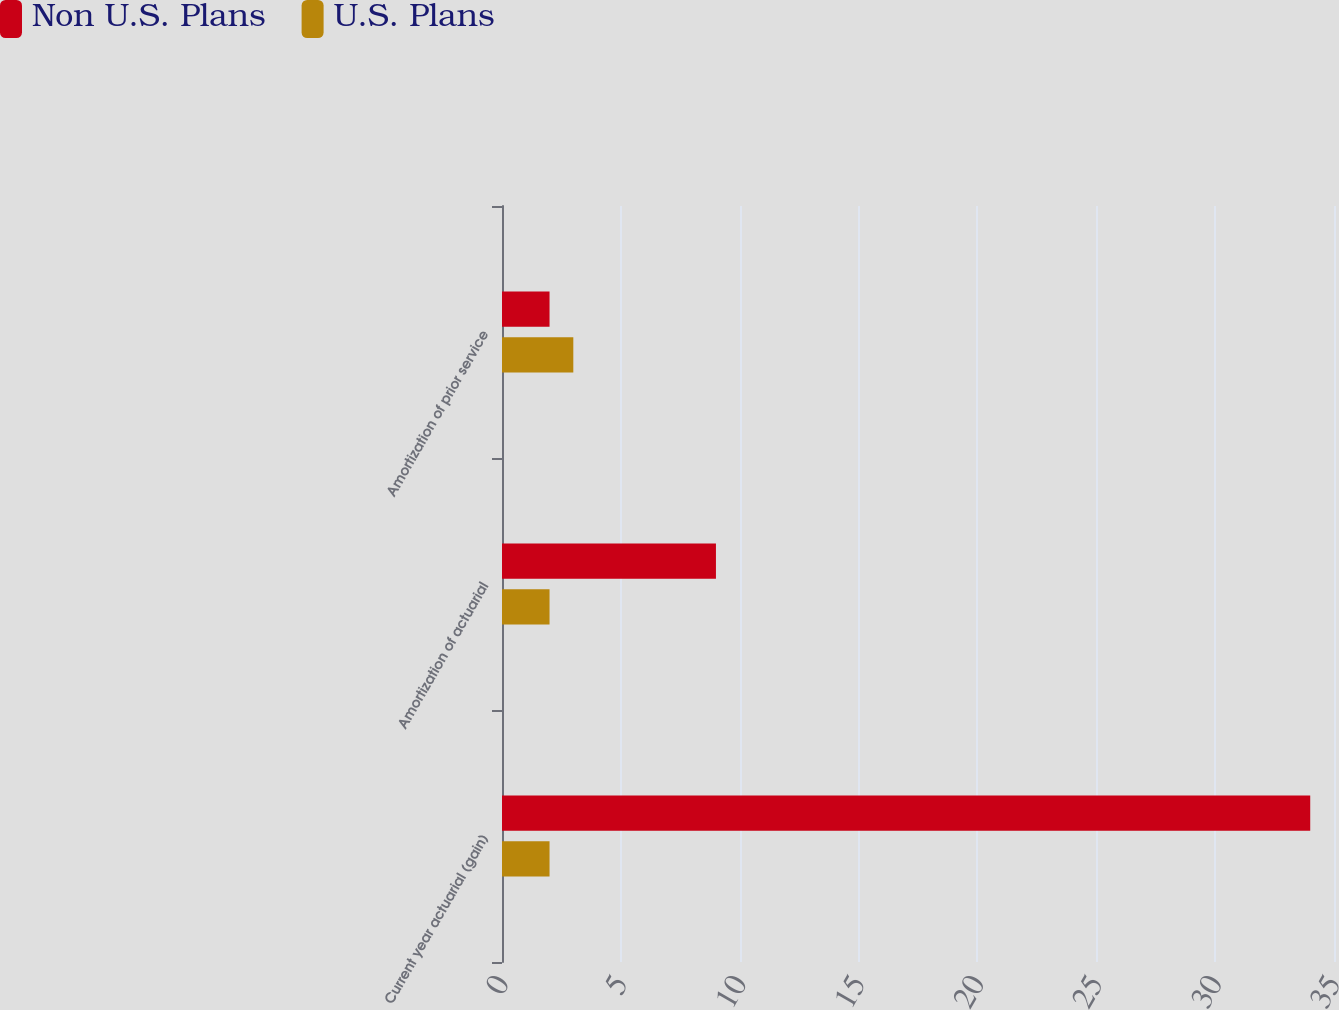Convert chart to OTSL. <chart><loc_0><loc_0><loc_500><loc_500><stacked_bar_chart><ecel><fcel>Current year actuarial (gain)<fcel>Amortization of actuarial<fcel>Amortization of prior service<nl><fcel>Non U.S. Plans<fcel>34<fcel>9<fcel>2<nl><fcel>U.S. Plans<fcel>2<fcel>2<fcel>3<nl></chart> 